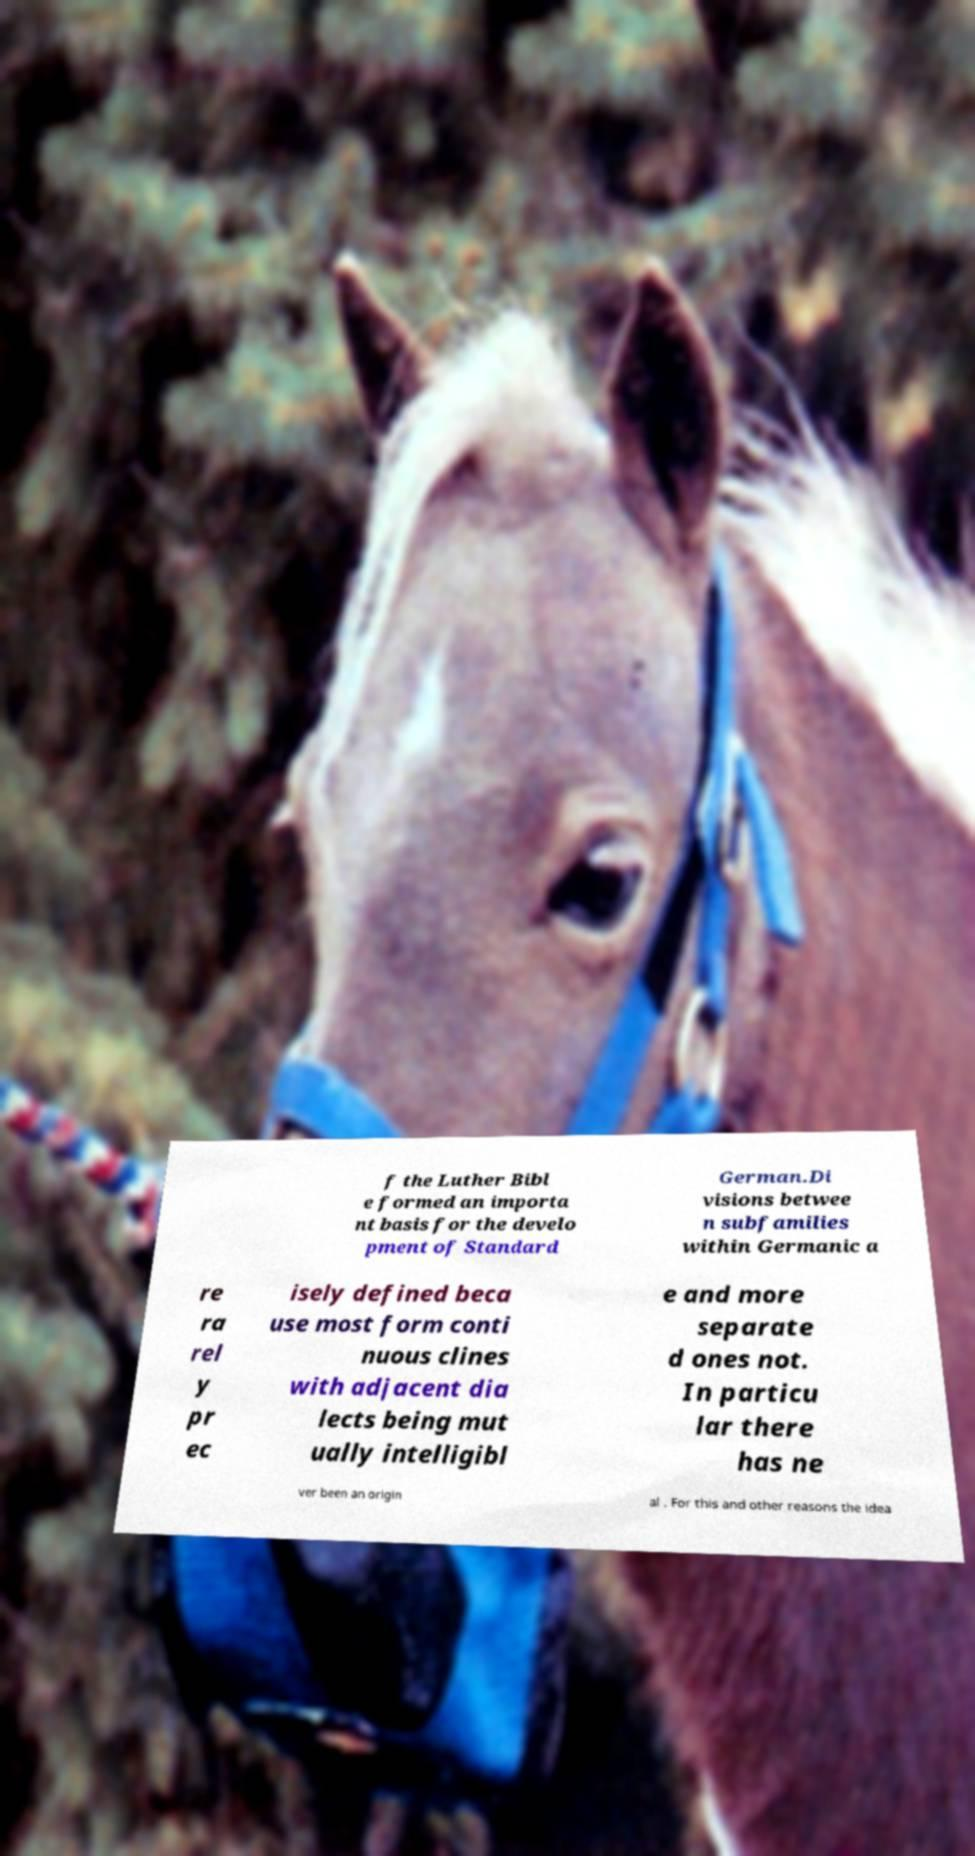Can you accurately transcribe the text from the provided image for me? f the Luther Bibl e formed an importa nt basis for the develo pment of Standard German.Di visions betwee n subfamilies within Germanic a re ra rel y pr ec isely defined beca use most form conti nuous clines with adjacent dia lects being mut ually intelligibl e and more separate d ones not. In particu lar there has ne ver been an origin al . For this and other reasons the idea 